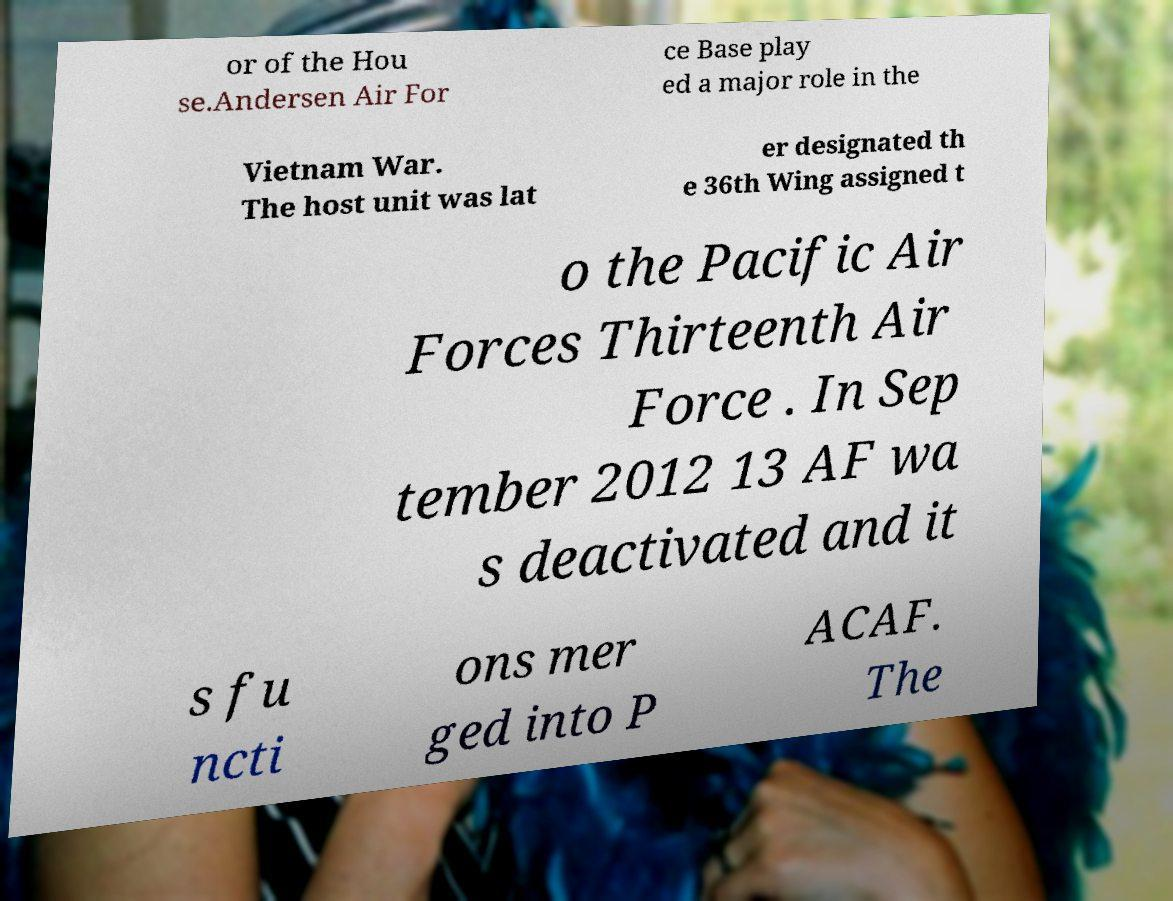For documentation purposes, I need the text within this image transcribed. Could you provide that? or of the Hou se.Andersen Air For ce Base play ed a major role in the Vietnam War. The host unit was lat er designated th e 36th Wing assigned t o the Pacific Air Forces Thirteenth Air Force . In Sep tember 2012 13 AF wa s deactivated and it s fu ncti ons mer ged into P ACAF. The 